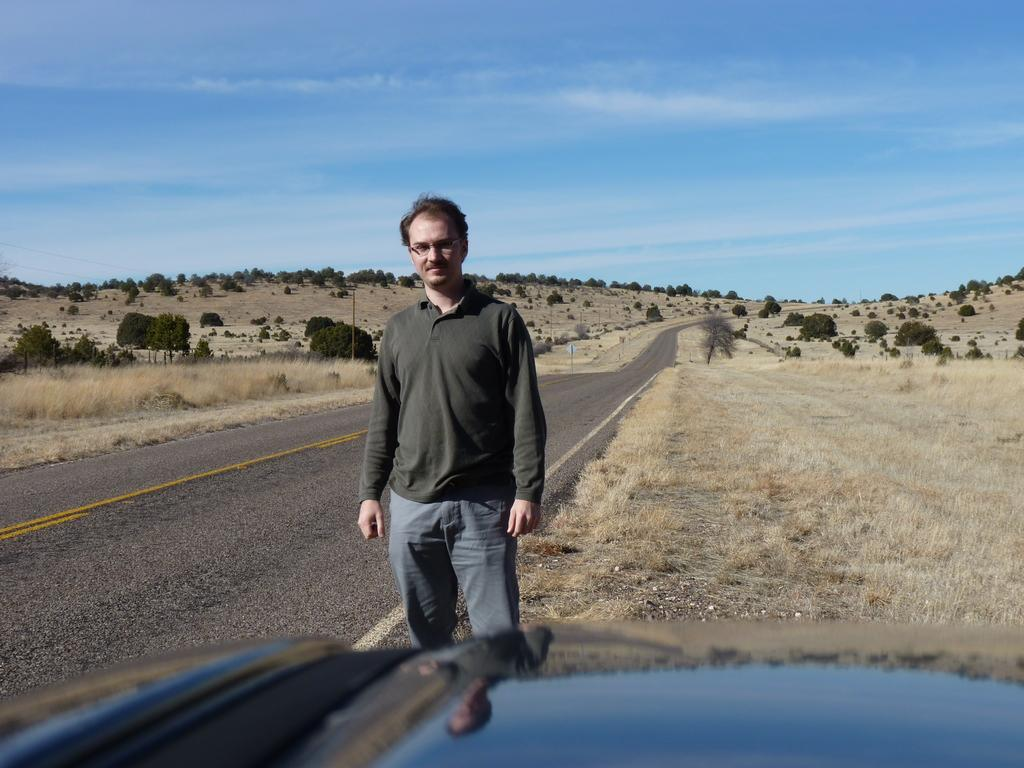What is the main subject in the foreground of the image? There is a man standing in the foreground of the image. What part of a car can be seen at the bottom of the image? The bonnet of a car is visible at the bottom of the image. What type of natural environment is visible in the background of the image? There is grassland and trees in the background of the image. What else can be seen in the background of the image? The sky is visible in the background of the image. What type of net can be seen in the image? There is no net present in the image. How many quinces are visible in the image? There are no quinces visible in the image. 